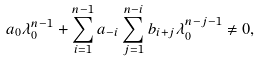Convert formula to latex. <formula><loc_0><loc_0><loc_500><loc_500>a _ { 0 } \lambda _ { 0 } ^ { n - 1 } + \sum _ { i = 1 } ^ { n - 1 } a _ { - i } \sum ^ { n - i } _ { j = 1 } b _ { i + j } \lambda _ { 0 } ^ { n - j - 1 } \ne 0 ,</formula> 